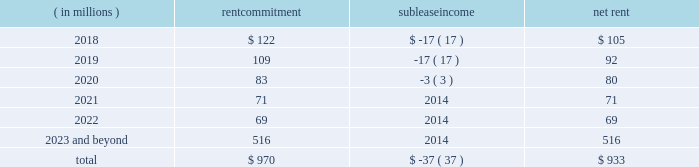Cash amounts for future minimum rental commitments under existing non- cancelable leases with a remaining term of more than one year , along with minimum sublease rental income to be received under non- cancelable subleases are shown in the table .
( in millions ) commitment sublease income net rent .
Legal & regulatory matters in the normal course of business both in the united states and abroad , the company and its subsidiaries are defendants in a number of legal proceedings and are often the subject of gov- ernment and regulatory proceedings , investigations and inqui- ries .
Many of these proceedings , investigations and inquiries relate to the ratings activity of s&p global ratings brought by issuers and alleged purchasers of rated securities .
In addition , various government and self- regulatory agencies frequently make inquiries and conduct investigations into our compliance with applicable laws and regulations , including those related to ratings activities and antitrust matters .
Any of these pro- ceedings , investigations or inquiries could ultimately result in adverse judgments , damages , fines , penalties or activity restrictions , which could adversely impact our consolidated financial condition , cash flows , business or competitive position .
The company believes that it has meritorious defenses to the pending claims and potential claims in the matters described below and is diligently pursuing these defenses , and in some cases working to reach an acceptable negotiated resolution .
However , in view of the uncertainty inherent in litigation and government and regulatory enforcement matters , we cannot predict the eventual outcome of these matters or the timing of their resolution , or in most cases reasonably estimate what the eventual judgments , damages , fines , penalties or impact of activity restrictions may be .
As a result , we cannot provide assurance that the outcome of the matters described below will not have a material adverse effect on our consolidated financial condition , cash flows , business or competitive posi- tion .
As litigation or the process to resolve pending matters progresses , as the case may be , we will continue to review the latest information available and assess our ability to predict the outcome of such matters and the effects , if any , on our con- solidated financial condition , cash flows , business and com- petitive position , which may require that we record liabilities in the consolidated financial statements in future periods .
With respect to the matters identified below , we have recog- nized a liability when both ( a ) a0 information available indicates that it is probable that a liability has been incurred as of the date of these financial statements and ( b ) a0the amount of loss can reasonably be estimated .
S&p global ratings financial crisis litigation the company and its subsidiaries continue to defend civil cases brought by private and public plaintiffs arising out of ratings activities prior to and during the global financial crisis of 2008 20132009 .
Included in these civil cases are several law- suits in australia against the company and standard & poor 2019s international , llc relating to alleged investment losses in collateralized debt obligations ( 201ccdos 201d ) rated by s&p global ratings .
We can provide no assurance that we will not be obli- gated to pay significant amounts in order to resolve these mat- ters on terms deemed acceptable .
U.s .
Securities and exchange commission as a nationally recognized statistical rating organization registered with the sec under section 15e of the securities exchange act of 1934 , s&p global ratings is in ongoing com- munication with the staff of the sec regarding compliance with its extensive obligations under the federal securities laws .
Although s&p global ratings seeks to promptly address any compliance issues that it detects or that the staff of the sec raises , there can be no assurance that the sec will not seek remedies against s&p global ratings for one or more compli- ance deficiencies .
Trani prosecutorial proceeding in 2014 , the prosecutor in the italian city of trani obtained criminal indictments against several current and former s&p global ratings managers and ratings analysts for alleged market manipulation , and against standard & poor 2019s credit market services europe under italy 2019s vicarious liability stat- ute , for having allegedly failed to properly supervise the ratings analysts and prevent them from committing market manipula- tion .
The prosecutor 2019s theories were based on various actions by s&p global ratings taken with respect to italian sovereign debt between may of 2011 and january of 2012 .
On march a030 , 2017 , following trial , the court in trani issued an oral verdict s&p global 2017 annual report 79 .
\\nwhat is the ratio of the rental commitment to the sublease income? 
Rationale: the ratio rental commitment expense was 26 times the sublease income
Computations: (970 / 37)
Answer: 26.21622. 